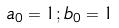Convert formula to latex. <formula><loc_0><loc_0><loc_500><loc_500>a _ { 0 } = 1 ; b _ { 0 } = 1</formula> 